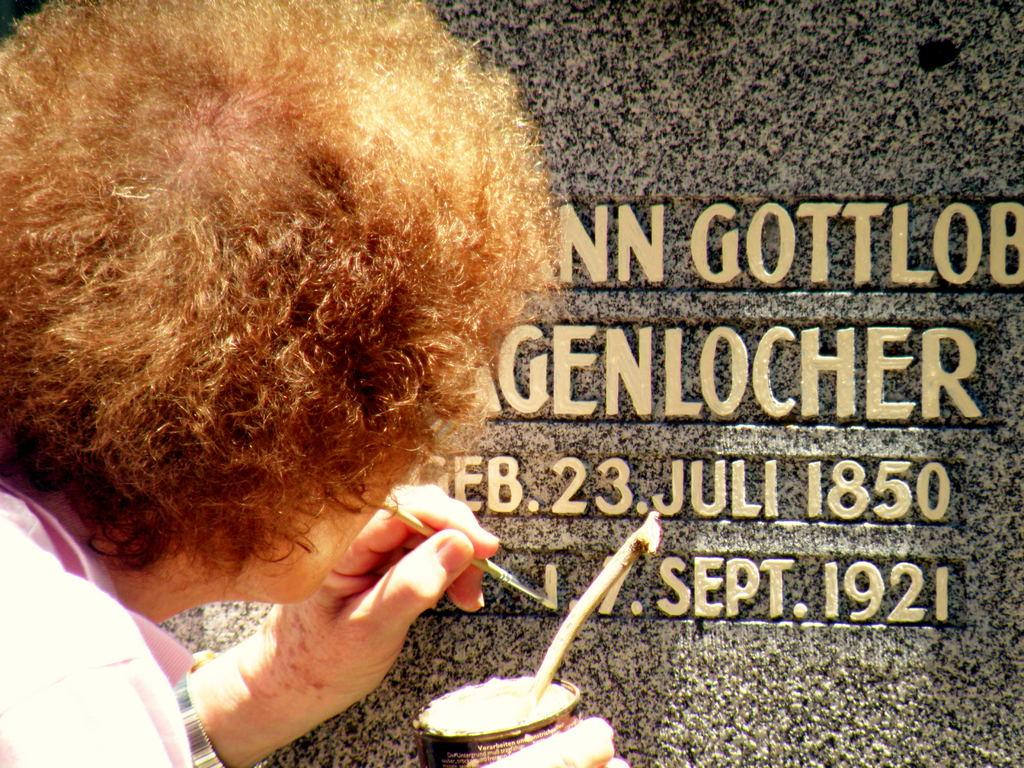What is the main subject of the image? There is a person in the image. What is the person doing in the image? The person is standing and writing text with paint on a wall. How many dimes can be seen on the wall in the image? There are no dimes present in the image; the person is using paint to write text on the wall. 